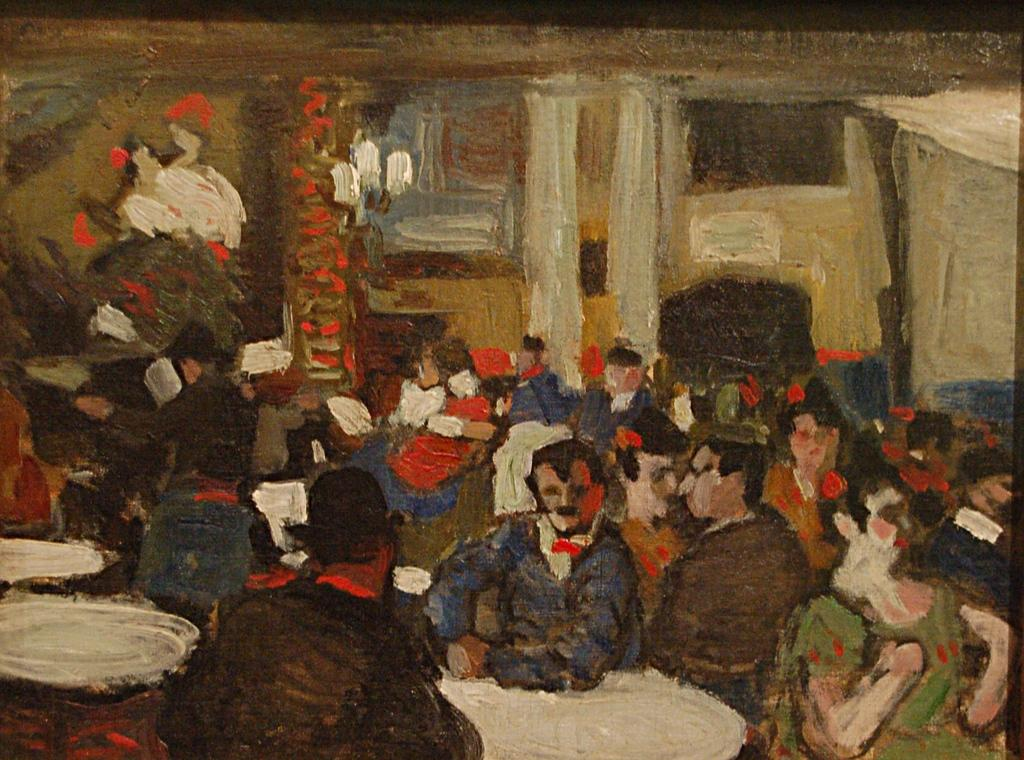What is the main subject of the image? The main subject of the image is a painting. What is depicted in the painting? The painting depicts people sitting over a place. What type of scent can be smelled coming from the painting in the image? There is no scent associated with the painting in the image, as it is a visual representation and not a physical object. 